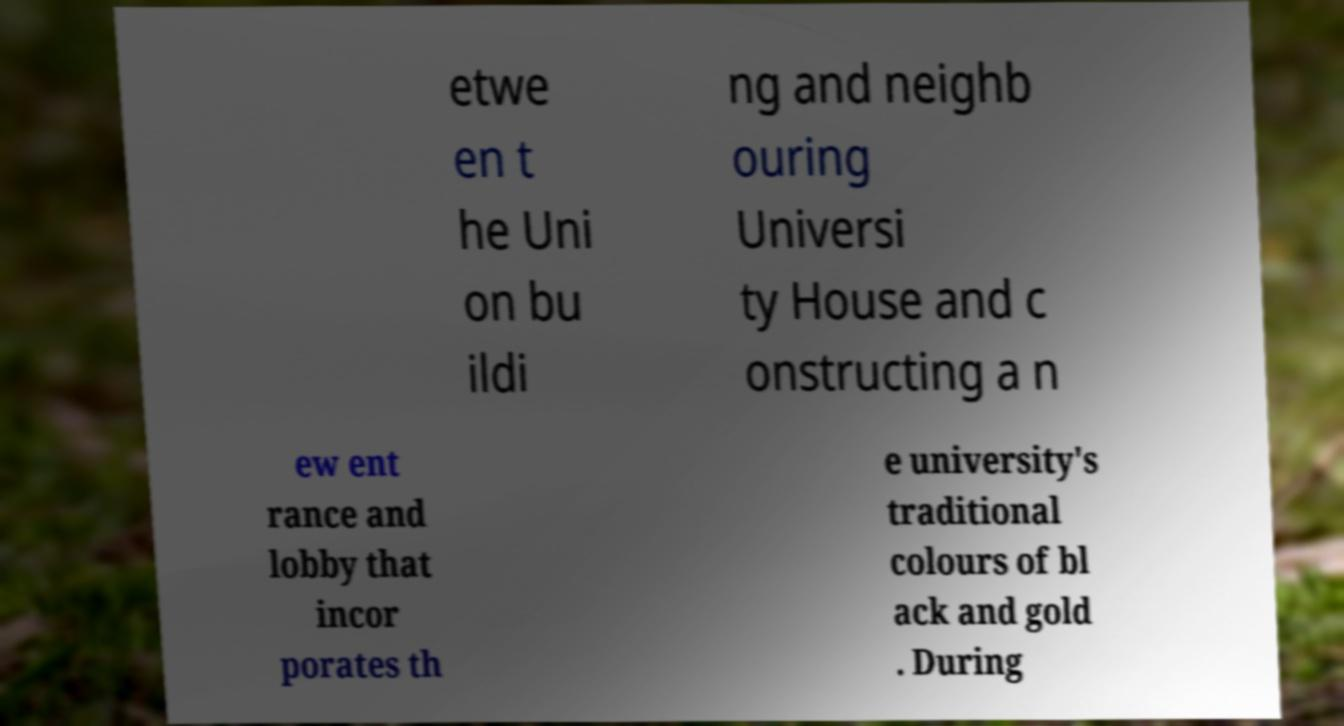There's text embedded in this image that I need extracted. Can you transcribe it verbatim? etwe en t he Uni on bu ildi ng and neighb ouring Universi ty House and c onstructing a n ew ent rance and lobby that incor porates th e university's traditional colours of bl ack and gold . During 